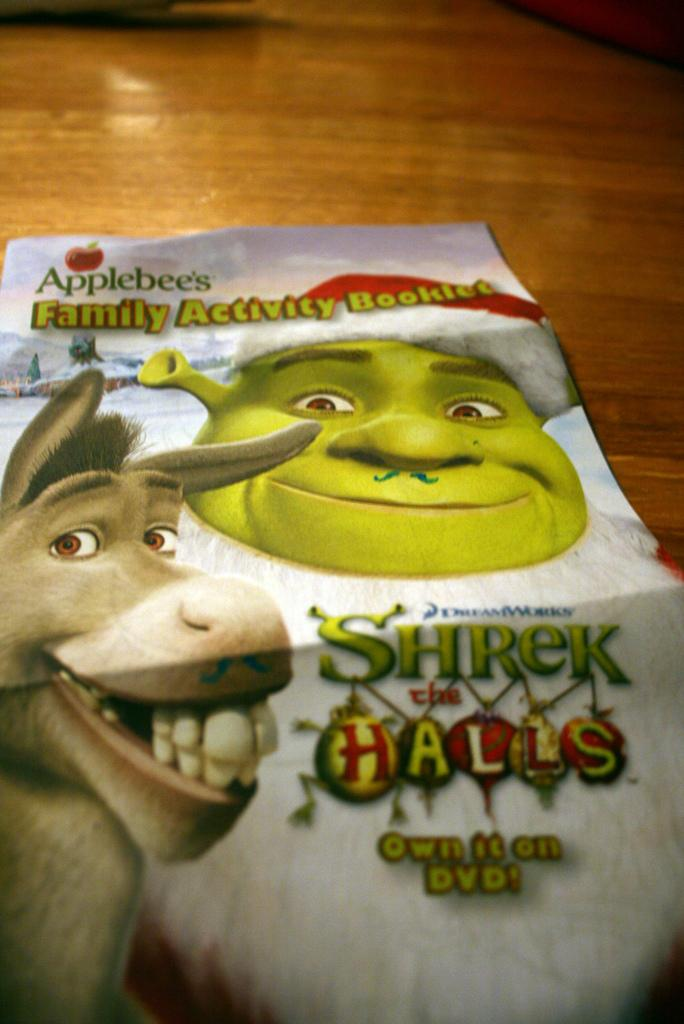What can be seen hanging on the wall in the image? There is a poster in the image. What type of hobbies are the fowl engaging in on the poster? There is no fowl present on the poster; it only features a poster. 